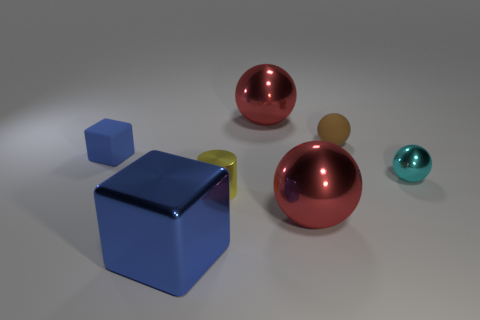Subtract all metallic spheres. How many spheres are left? 1 Subtract all blue cubes. How many red spheres are left? 2 Subtract all cyan balls. How many balls are left? 3 Subtract all cylinders. How many objects are left? 6 Add 1 blue things. How many objects exist? 8 Subtract 1 spheres. How many spheres are left? 3 Subtract all matte objects. Subtract all brown cylinders. How many objects are left? 5 Add 2 small yellow objects. How many small yellow objects are left? 3 Add 1 metallic blocks. How many metallic blocks exist? 2 Subtract 0 gray cubes. How many objects are left? 7 